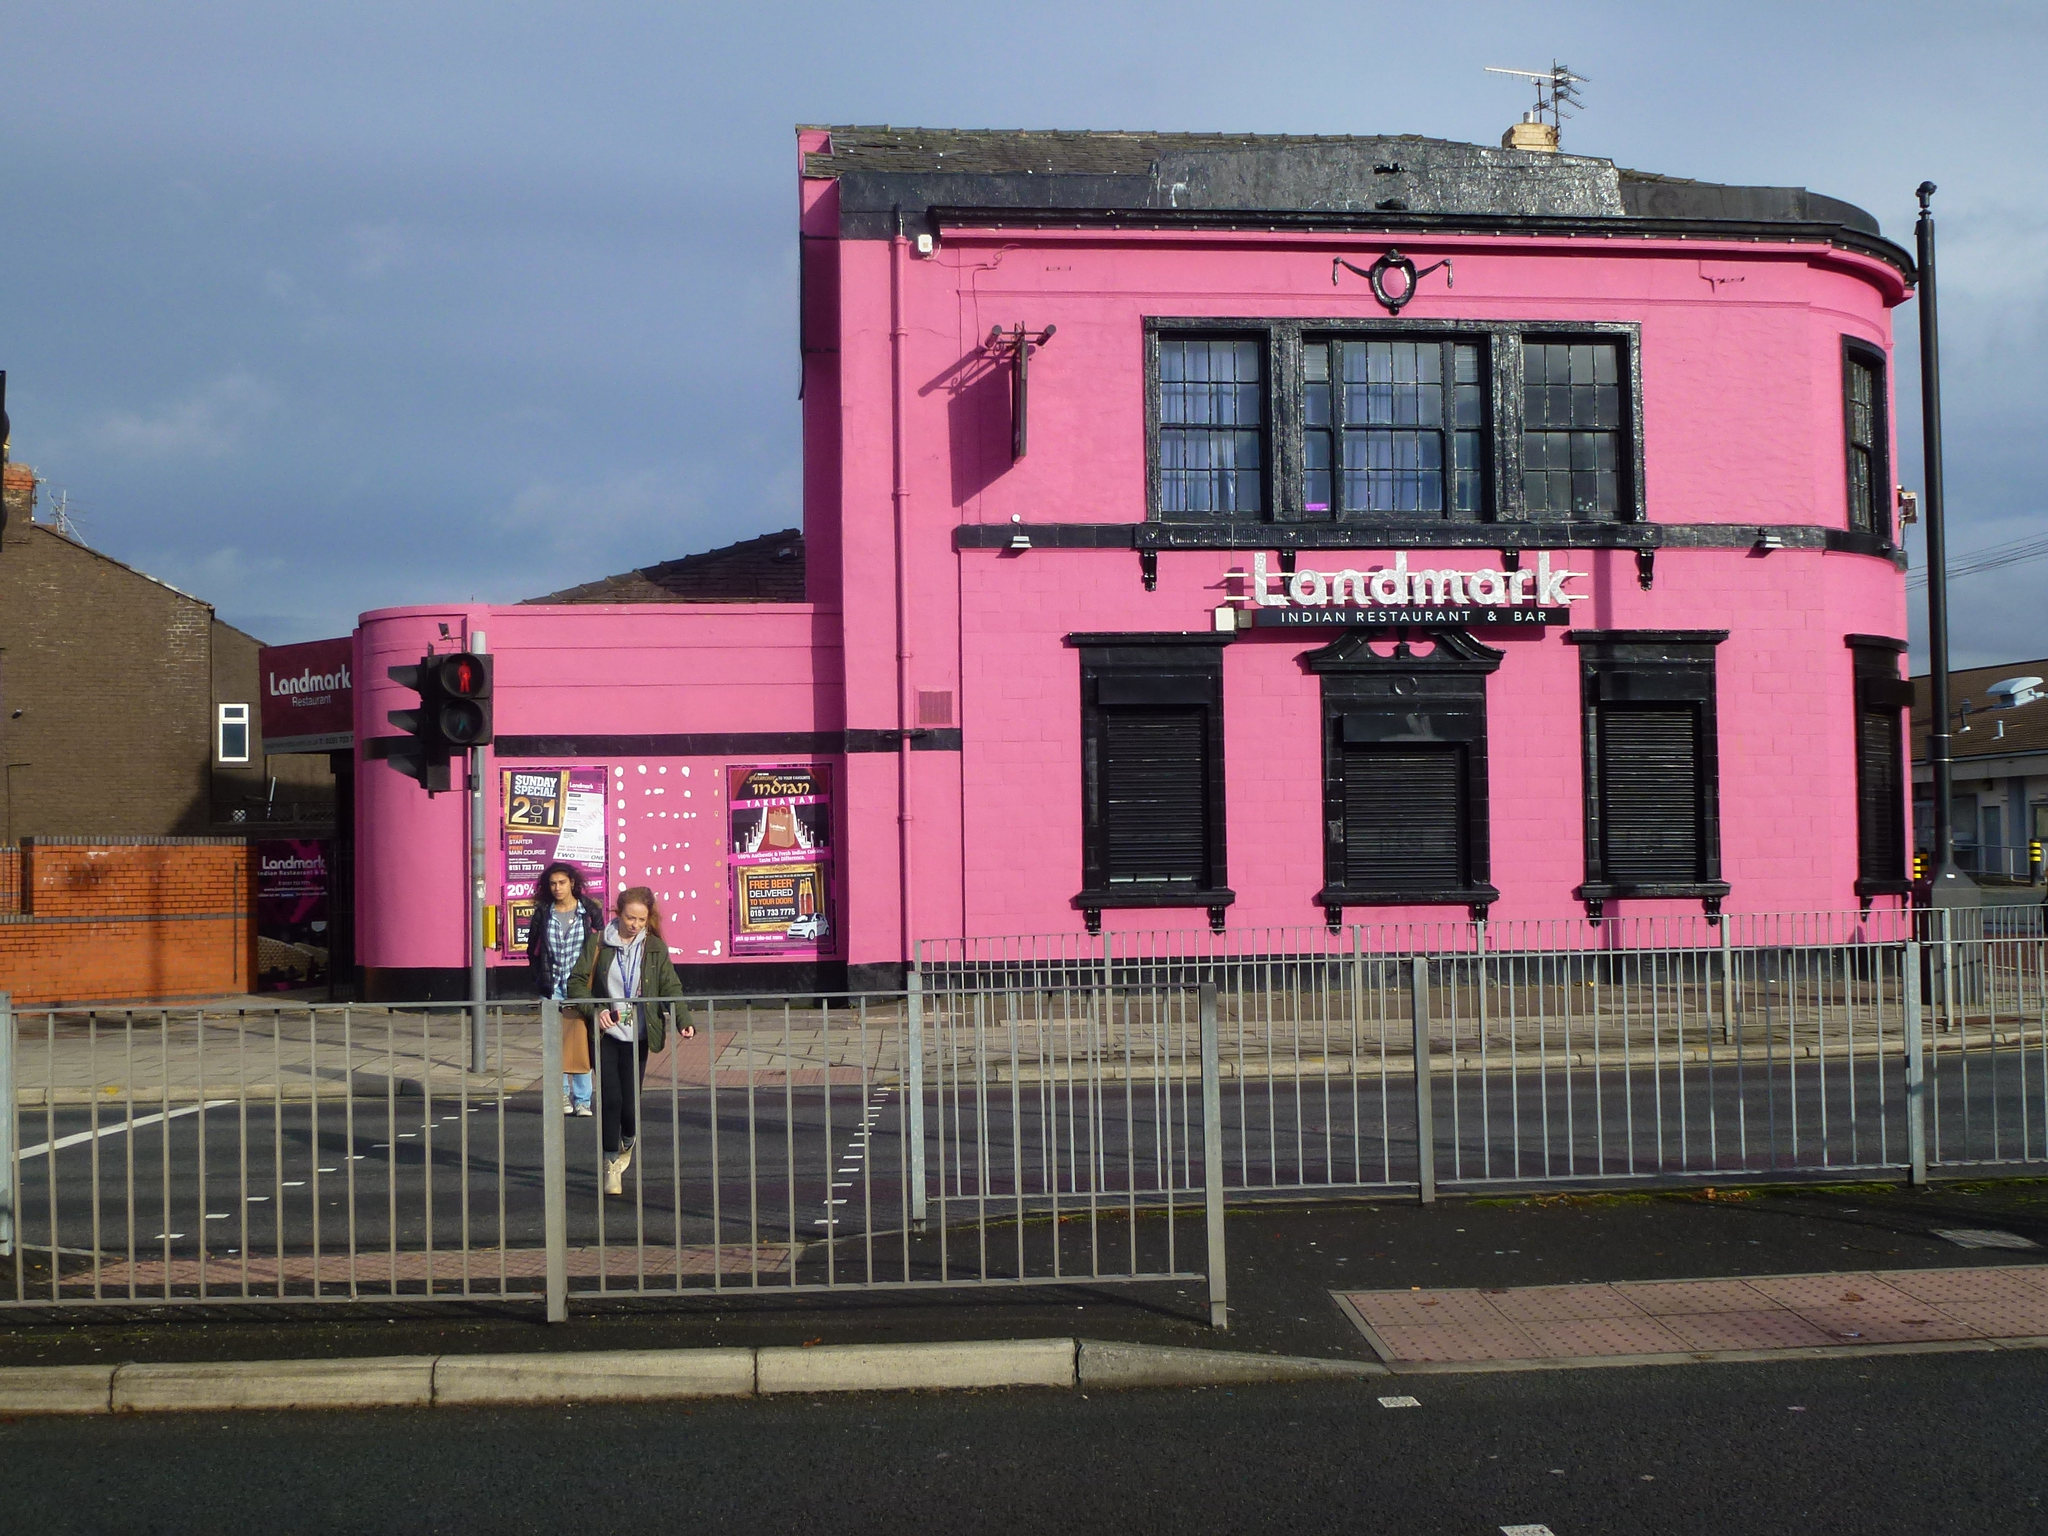Describe this image in one or two sentences. In the image we can see there are people standing on the road and there are iron pole fencing kept on the road. Behind there are buildings and its written ¨Landmark¨ on the building. There is a traffic light pole and the sky is clear. 